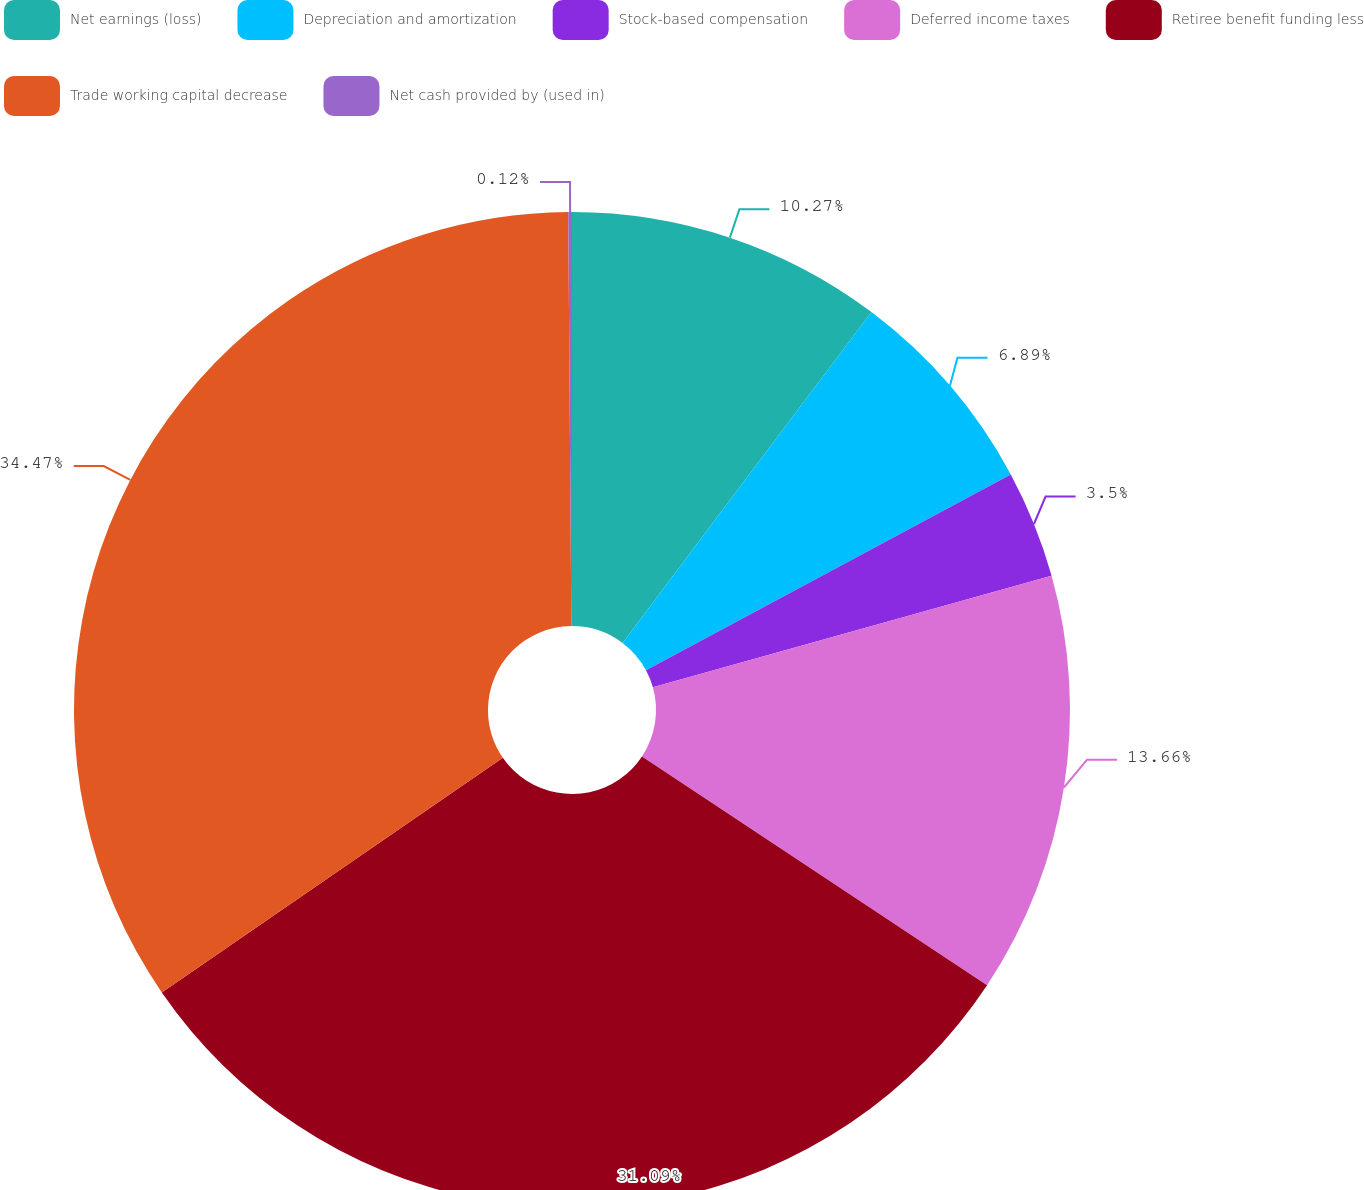<chart> <loc_0><loc_0><loc_500><loc_500><pie_chart><fcel>Net earnings (loss)<fcel>Depreciation and amortization<fcel>Stock-based compensation<fcel>Deferred income taxes<fcel>Retiree benefit funding less<fcel>Trade working capital decrease<fcel>Net cash provided by (used in)<nl><fcel>10.27%<fcel>6.89%<fcel>3.5%<fcel>13.66%<fcel>31.09%<fcel>34.48%<fcel>0.12%<nl></chart> 